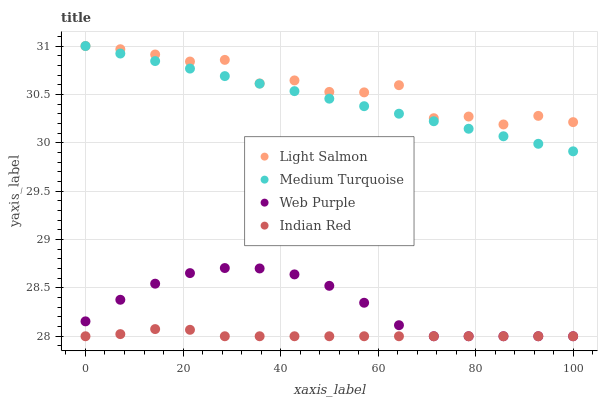Does Indian Red have the minimum area under the curve?
Answer yes or no. Yes. Does Light Salmon have the maximum area under the curve?
Answer yes or no. Yes. Does Web Purple have the minimum area under the curve?
Answer yes or no. No. Does Web Purple have the maximum area under the curve?
Answer yes or no. No. Is Medium Turquoise the smoothest?
Answer yes or no. Yes. Is Light Salmon the roughest?
Answer yes or no. Yes. Is Web Purple the smoothest?
Answer yes or no. No. Is Web Purple the roughest?
Answer yes or no. No. Does Indian Red have the lowest value?
Answer yes or no. Yes. Does Light Salmon have the lowest value?
Answer yes or no. No. Does Medium Turquoise have the highest value?
Answer yes or no. Yes. Does Web Purple have the highest value?
Answer yes or no. No. Is Web Purple less than Medium Turquoise?
Answer yes or no. Yes. Is Medium Turquoise greater than Indian Red?
Answer yes or no. Yes. Does Light Salmon intersect Medium Turquoise?
Answer yes or no. Yes. Is Light Salmon less than Medium Turquoise?
Answer yes or no. No. Is Light Salmon greater than Medium Turquoise?
Answer yes or no. No. Does Web Purple intersect Medium Turquoise?
Answer yes or no. No. 